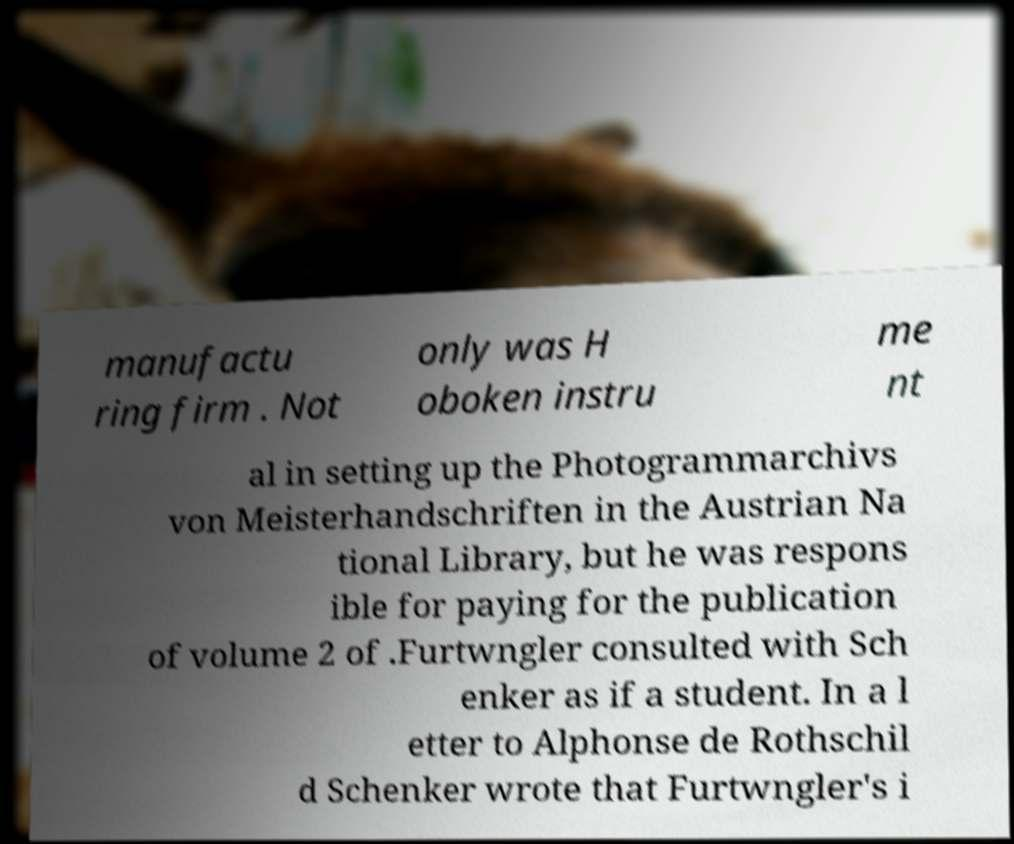Can you accurately transcribe the text from the provided image for me? manufactu ring firm . Not only was H oboken instru me nt al in setting up the Photogrammarchivs von Meisterhandschriften in the Austrian Na tional Library, but he was respons ible for paying for the publication of volume 2 of .Furtwngler consulted with Sch enker as if a student. In a l etter to Alphonse de Rothschil d Schenker wrote that Furtwngler's i 